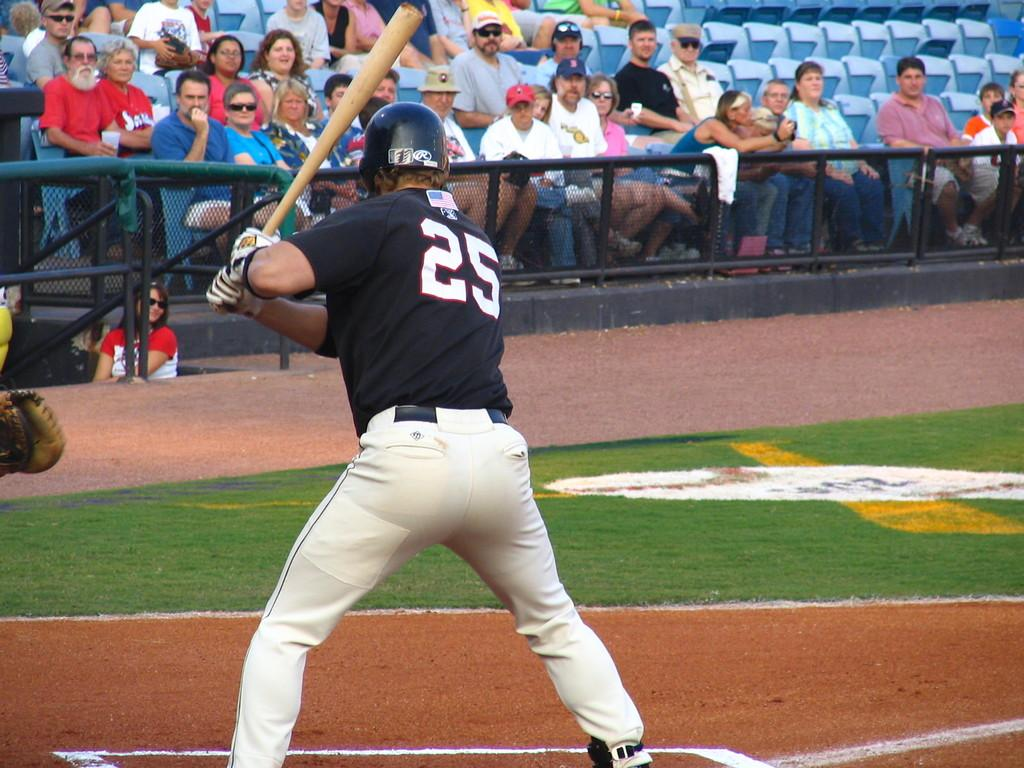<image>
Render a clear and concise summary of the photo. Baseball player number 25 is swinging a bat. 